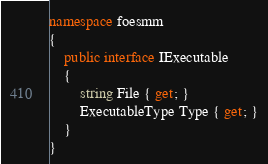Convert code to text. <code><loc_0><loc_0><loc_500><loc_500><_C#_>namespace foesmm
{
    public interface IExecutable
    {
        string File { get; }
        ExecutableType Type { get; }
    }
}</code> 